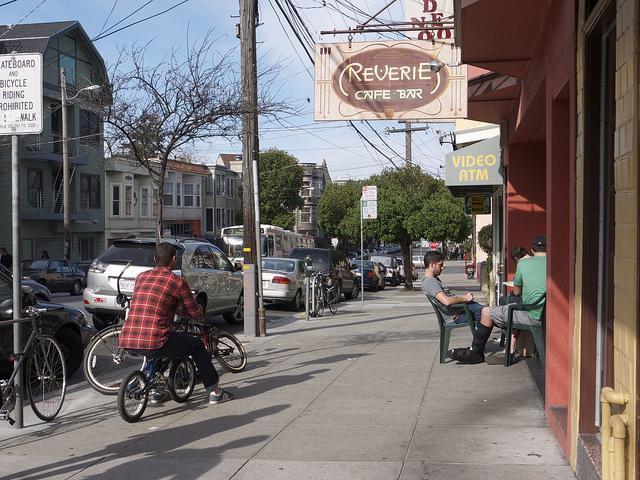How many people are in the picture?
Give a very brief answer. 2. How many bicycles are in the photo?
Give a very brief answer. 3. How many cars are visible?
Give a very brief answer. 3. 